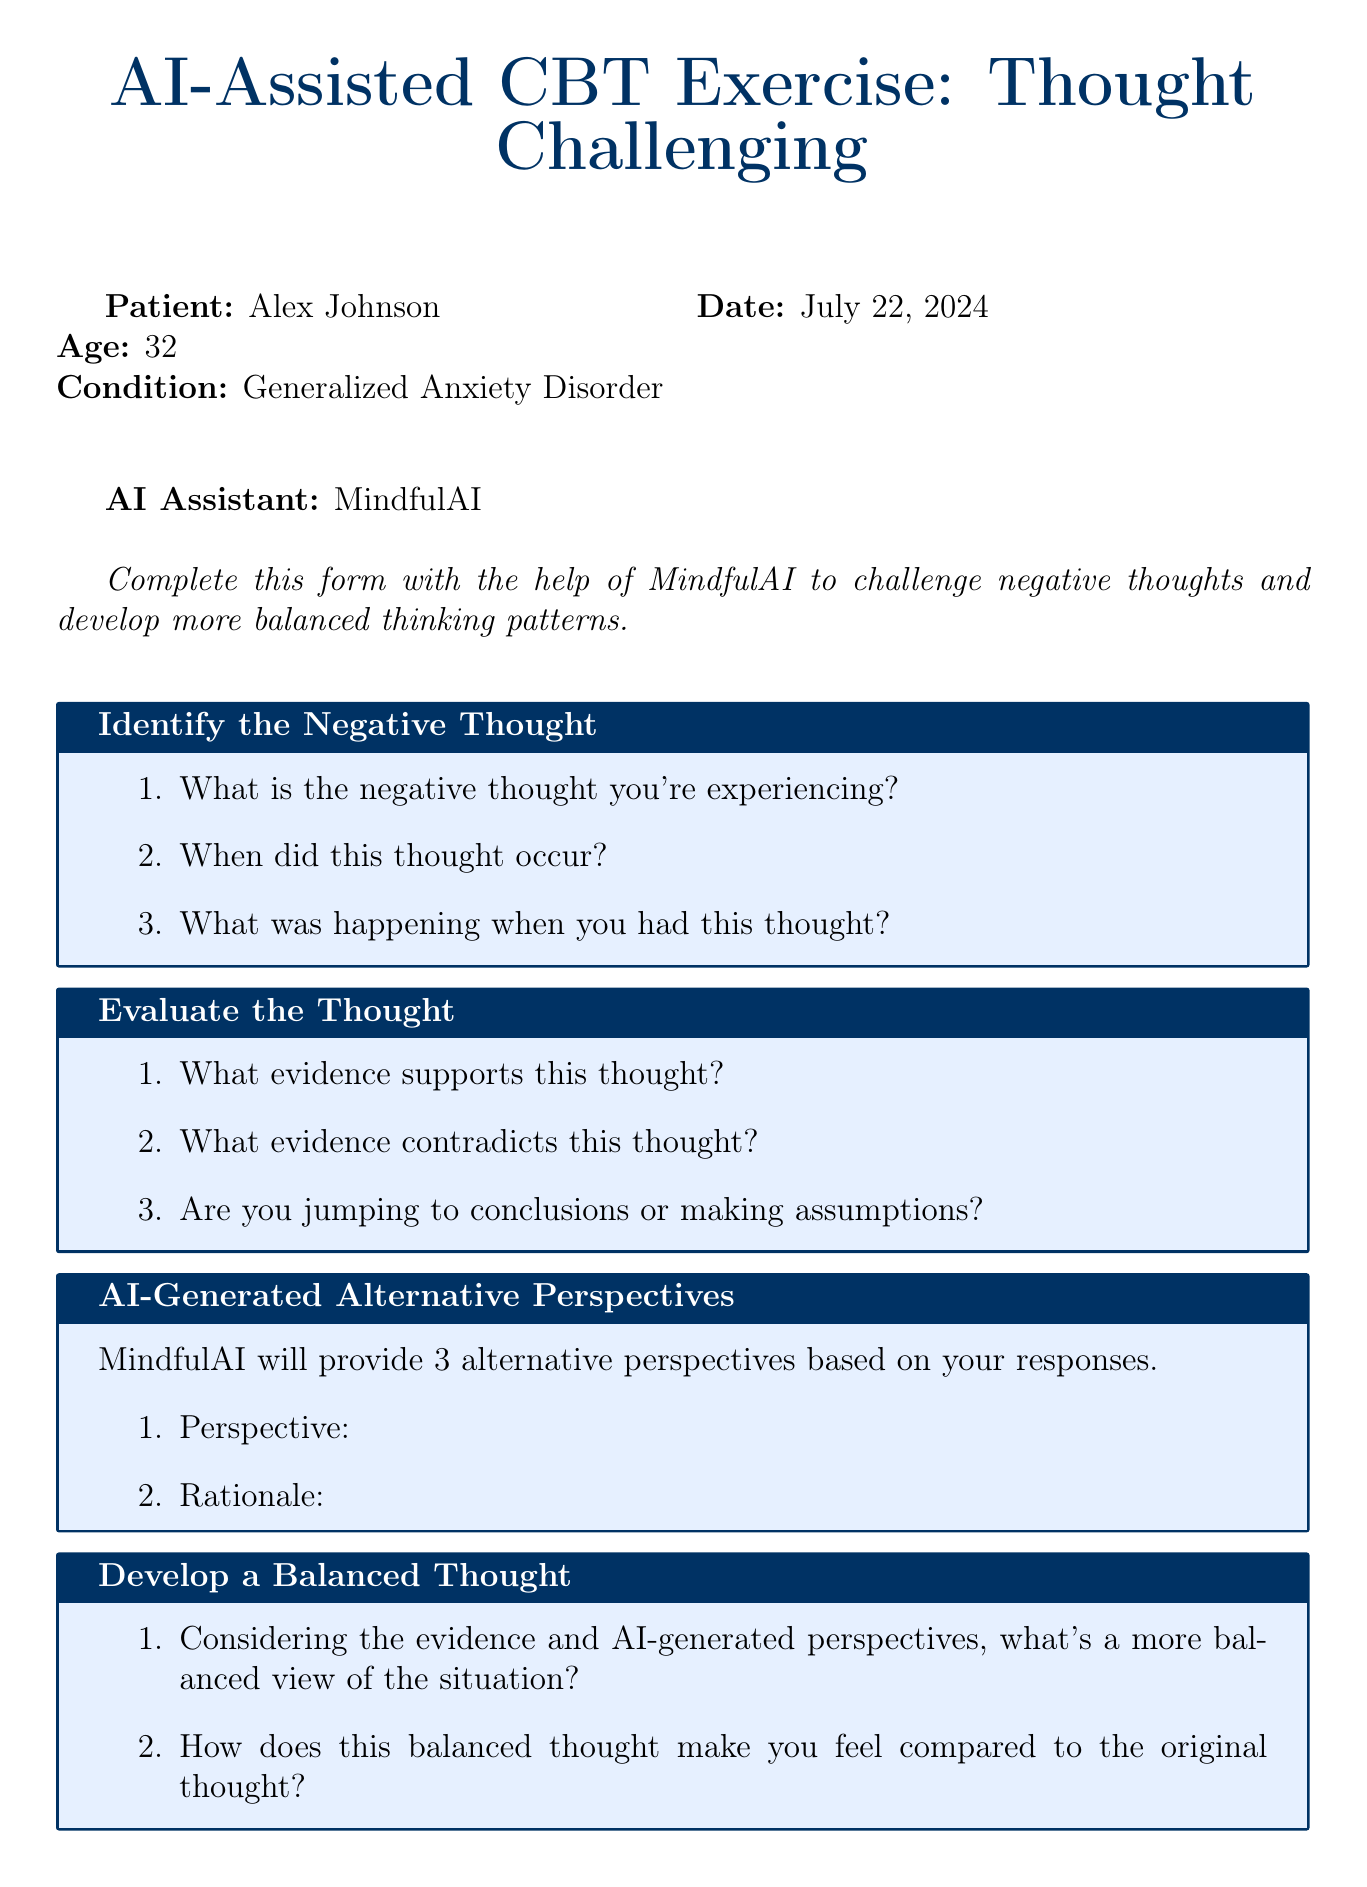What is the name of the patient? The name of the patient is listed in the document under patient info.
Answer: Alex Johnson What is the patient's age? The age of the patient is specified in the document.
Answer: 32 What condition does the patient have? The patient's condition is stated in the document.
Answer: Generalized Anxiety Disorder Who is the AI assistant? The AI assistant's name is mentioned at the top of the document.
Answer: MindfulAI What is the title of the exercise? The title of the document is provided at the beginning.
Answer: AI-Assisted CBT Exercise: Thought Challenging What is the date for the follow-up reminder? The scheduled follow-up date is included in the follow-up section of the document.
Answer: {{current_date + 7 days}} How many alternative perspectives will MindfulAI provide? The document specifies the number of perspectives provided by the AI.
Answer: 3 How helpful was the exercise rated on a scale from 1 to 10? The helpfulness of the exercise is to be rated on a specific scale mentioned in the feedback section.
Answer: 1 to 10 What is the purpose of the action plan section? The action plan section includes actions based on the new balanced perspective.
Answer: To identify actions based on new perspective 